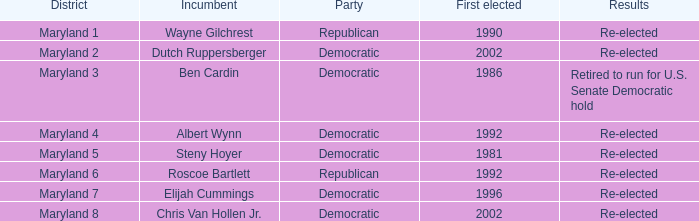What is the political affiliation of the maryland 6th district? Republican. 